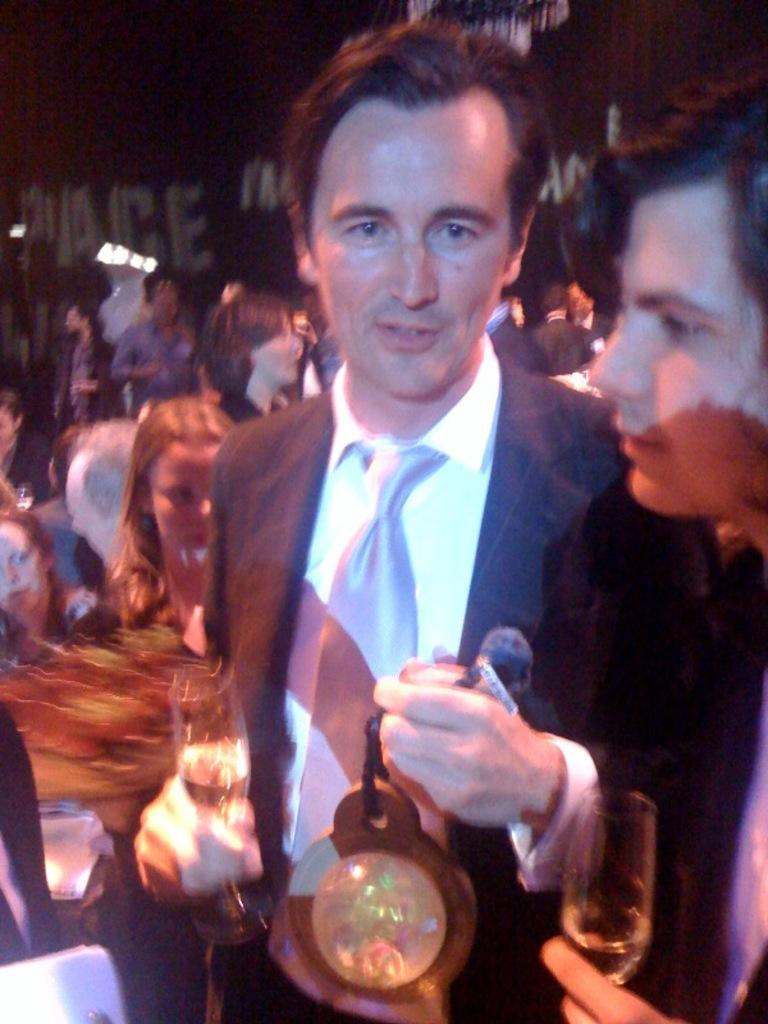What is happening in the image? There are people standing in the image. What are some of the people holding in their hands? Some of the people are holding glasses in their hands. Can you describe the man in the image? There is a man holding a fancy ball in his hand. What type of crime is being committed in the image? There is no crime being committed in the image; it simply shows people standing and holding glasses and a fancy ball. What effect does the fancy ball have on the people in the image? The fancy ball does not have any effect on the people in the image; it is just an object being held by the man. 